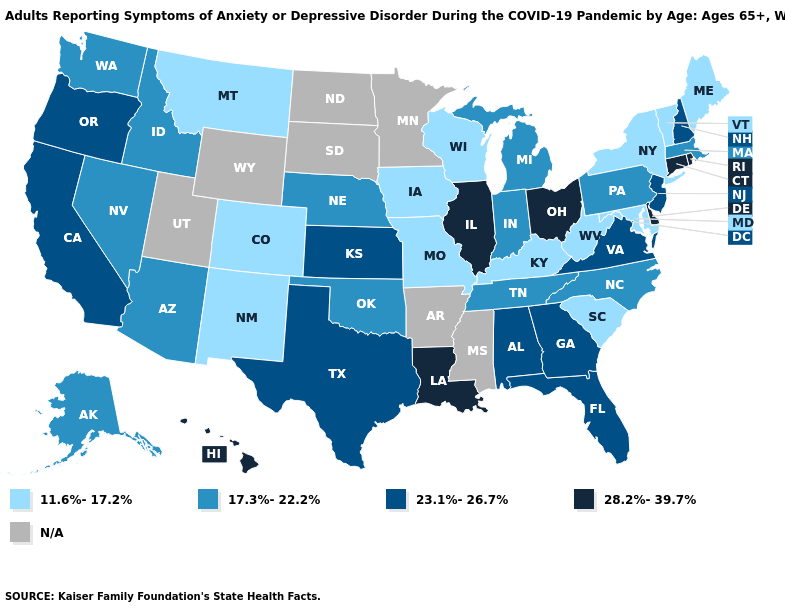Which states hav the highest value in the West?
Be succinct. Hawaii. Does Kentucky have the lowest value in the South?
Short answer required. Yes. Which states have the lowest value in the Northeast?
Be succinct. Maine, New York, Vermont. Among the states that border Delaware , which have the highest value?
Be succinct. New Jersey. What is the value of Montana?
Keep it brief. 11.6%-17.2%. Is the legend a continuous bar?
Answer briefly. No. What is the lowest value in the Northeast?
Be succinct. 11.6%-17.2%. Among the states that border Texas , which have the highest value?
Be succinct. Louisiana. Name the states that have a value in the range 17.3%-22.2%?
Write a very short answer. Alaska, Arizona, Idaho, Indiana, Massachusetts, Michigan, Nebraska, Nevada, North Carolina, Oklahoma, Pennsylvania, Tennessee, Washington. Name the states that have a value in the range 23.1%-26.7%?
Keep it brief. Alabama, California, Florida, Georgia, Kansas, New Hampshire, New Jersey, Oregon, Texas, Virginia. What is the value of South Carolina?
Write a very short answer. 11.6%-17.2%. Does the first symbol in the legend represent the smallest category?
Short answer required. Yes. Among the states that border Ohio , which have the lowest value?
Short answer required. Kentucky, West Virginia. 